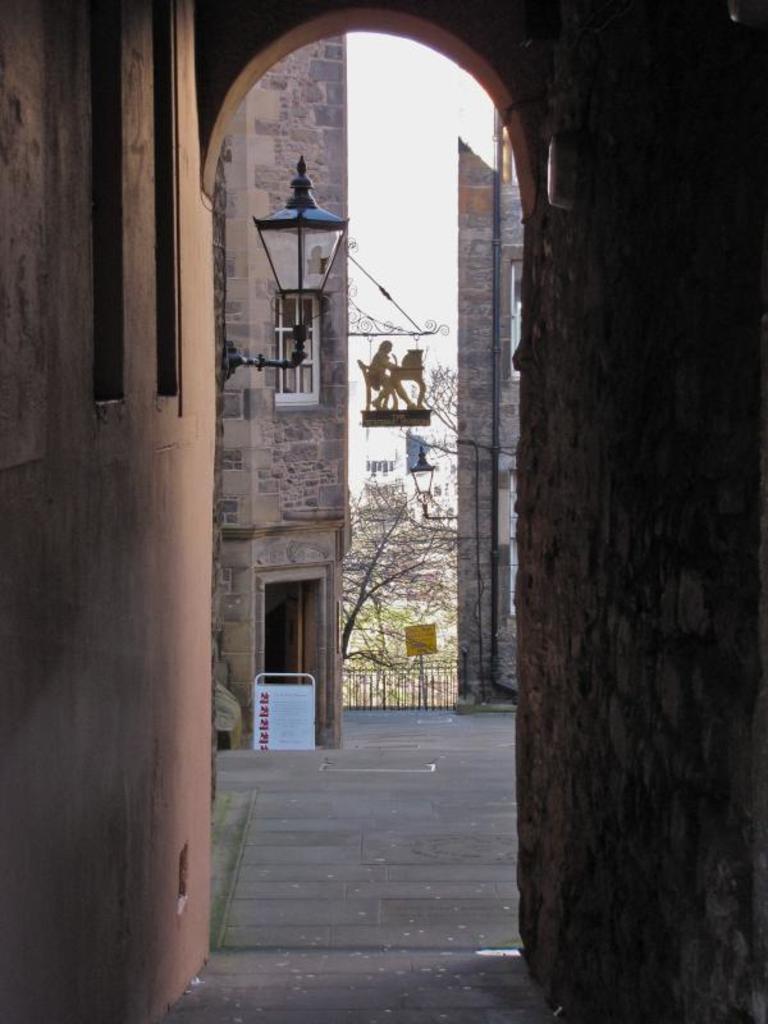Describe this image in one or two sentences. In the image we can see a building, on the building there is a light. Top of the image there is sky. Bottom of the image there is a fencing. Behind the fencing there are some trees. 